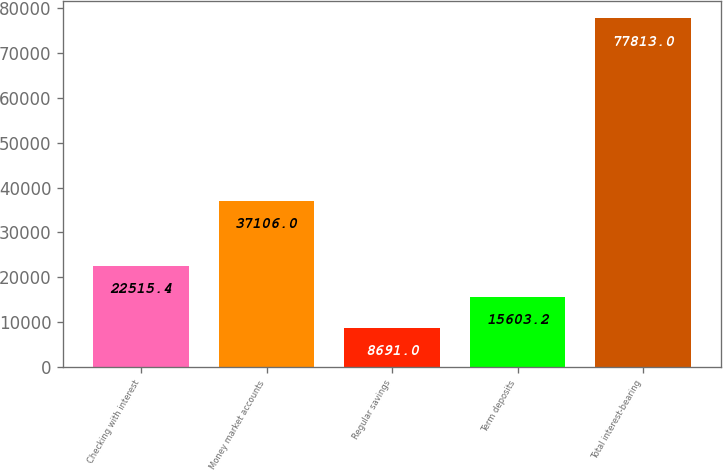Convert chart to OTSL. <chart><loc_0><loc_0><loc_500><loc_500><bar_chart><fcel>Checking with interest<fcel>Money market accounts<fcel>Regular savings<fcel>Term deposits<fcel>Total interest-bearing<nl><fcel>22515.4<fcel>37106<fcel>8691<fcel>15603.2<fcel>77813<nl></chart> 